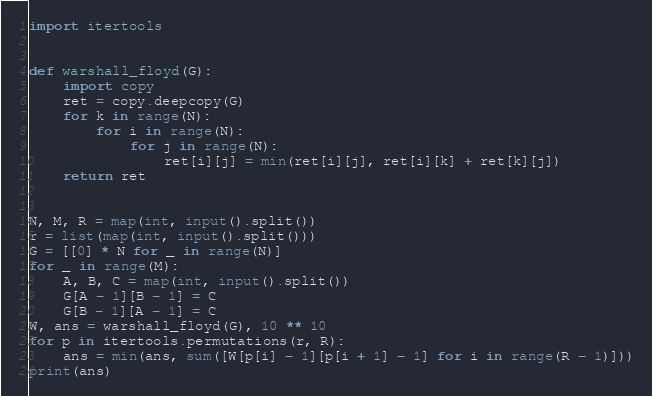Convert code to text. <code><loc_0><loc_0><loc_500><loc_500><_Python_>import itertools


def warshall_floyd(G):
    import copy
    ret = copy.deepcopy(G)
    for k in range(N):
        for i in range(N):
            for j in range(N):
                ret[i][j] = min(ret[i][j], ret[i][k] + ret[k][j])
    return ret


N, M, R = map(int, input().split())
r = list(map(int, input().split()))
G = [[0] * N for _ in range(N)]
for _ in range(M):
    A, B, C = map(int, input().split())
    G[A - 1][B - 1] = C
    G[B - 1][A - 1] = C
W, ans = warshall_floyd(G), 10 ** 10
for p in itertools.permutations(r, R):
    ans = min(ans, sum([W[p[i] - 1][p[i + 1] - 1] for i in range(R - 1)]))
print(ans)
</code> 